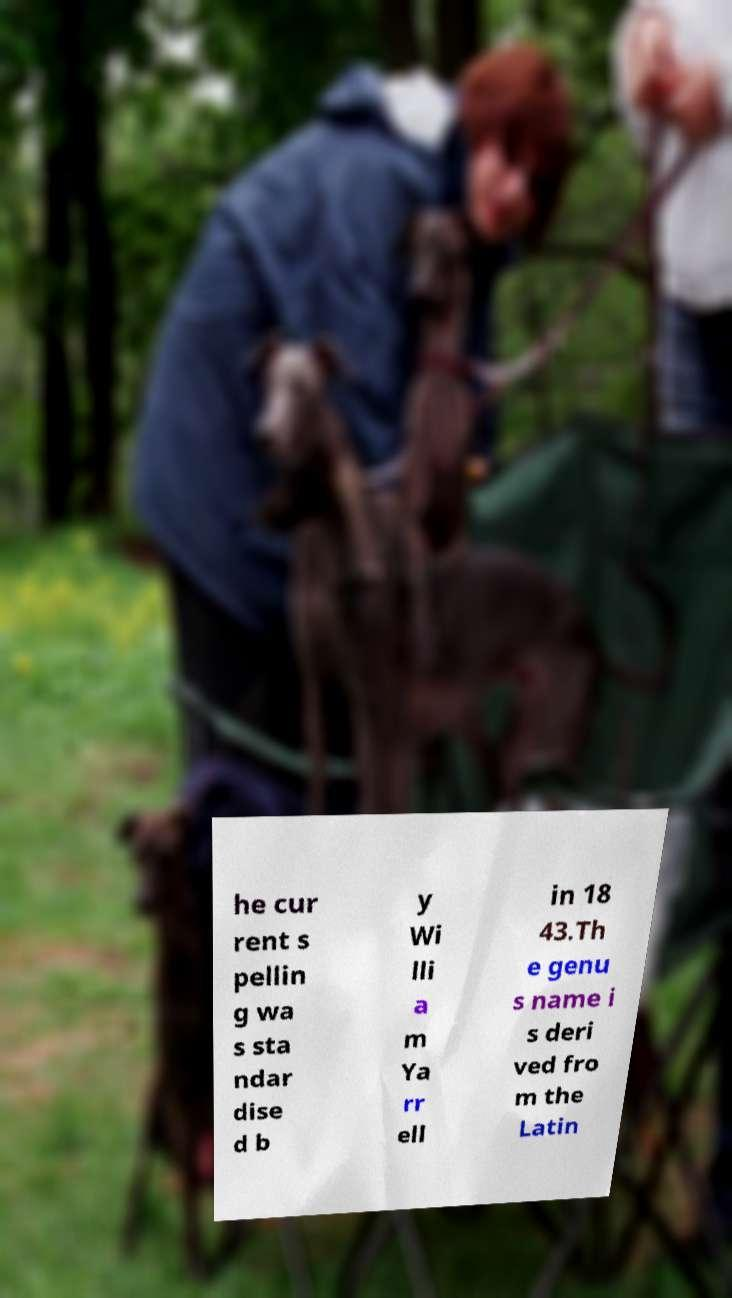There's text embedded in this image that I need extracted. Can you transcribe it verbatim? he cur rent s pellin g wa s sta ndar dise d b y Wi lli a m Ya rr ell in 18 43.Th e genu s name i s deri ved fro m the Latin 